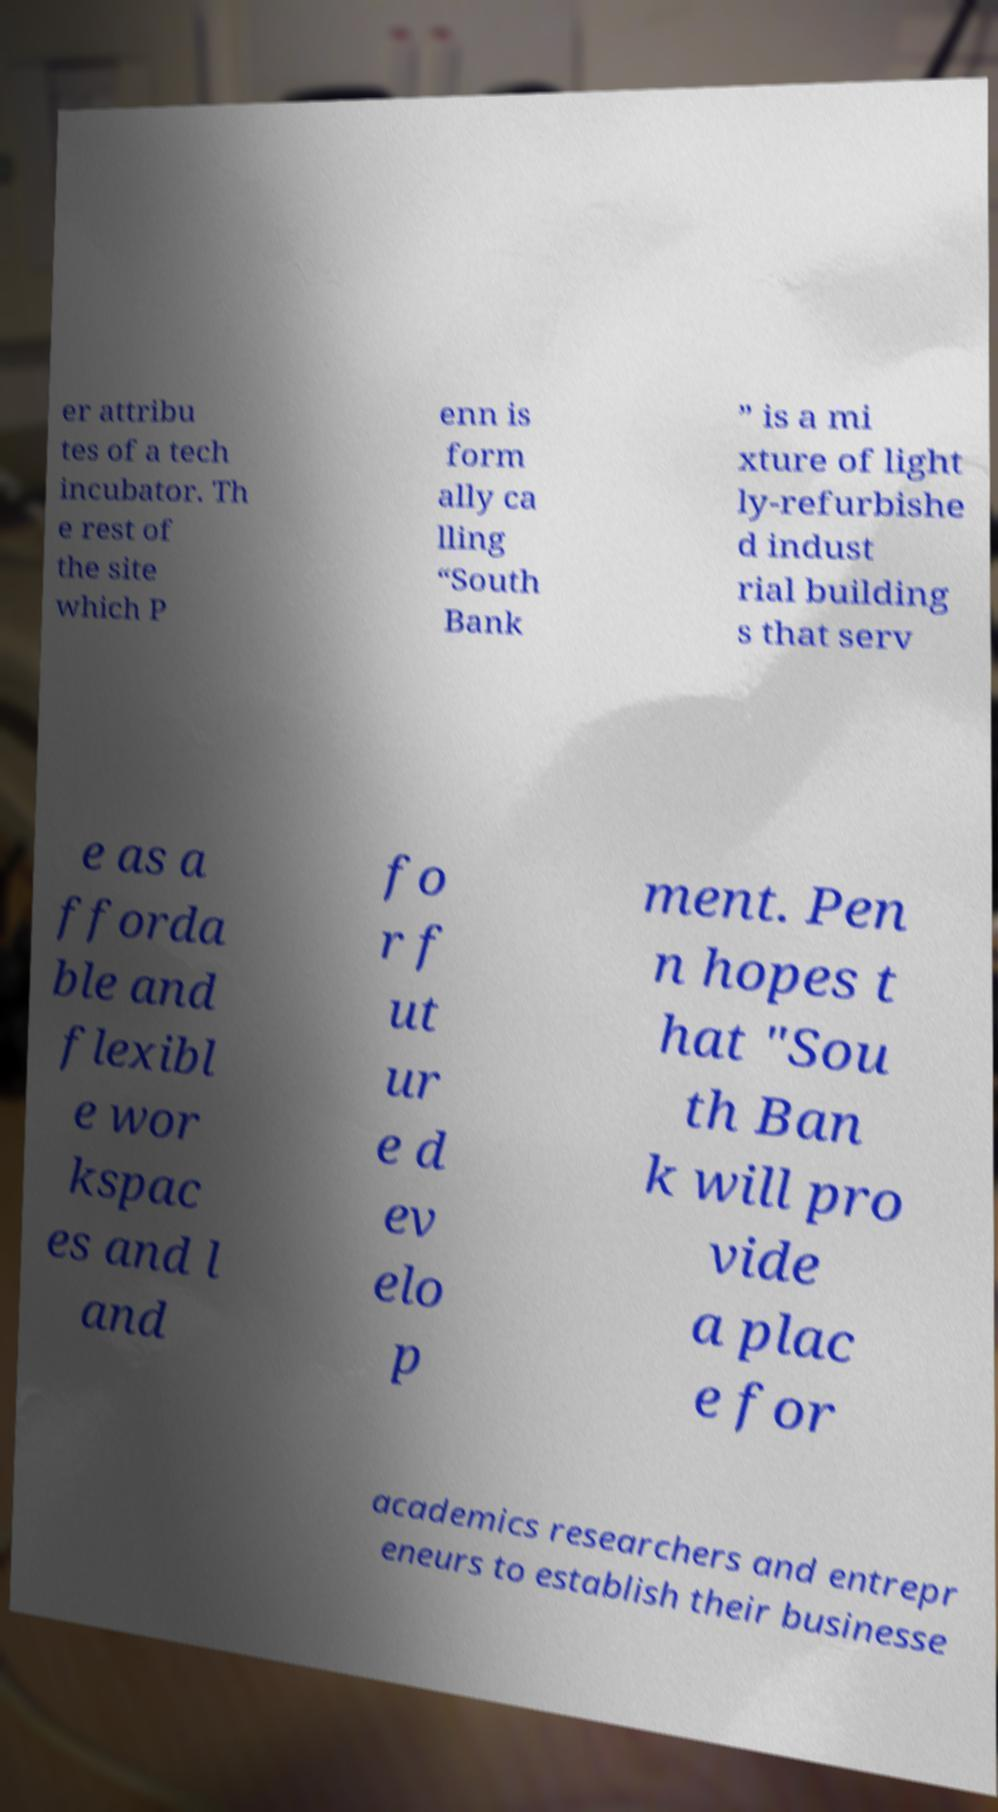What messages or text are displayed in this image? I need them in a readable, typed format. er attribu tes of a tech incubator. Th e rest of the site which P enn is form ally ca lling “South Bank ” is a mi xture of light ly-refurbishe d indust rial building s that serv e as a fforda ble and flexibl e wor kspac es and l and fo r f ut ur e d ev elo p ment. Pen n hopes t hat "Sou th Ban k will pro vide a plac e for academics researchers and entrepr eneurs to establish their businesse 